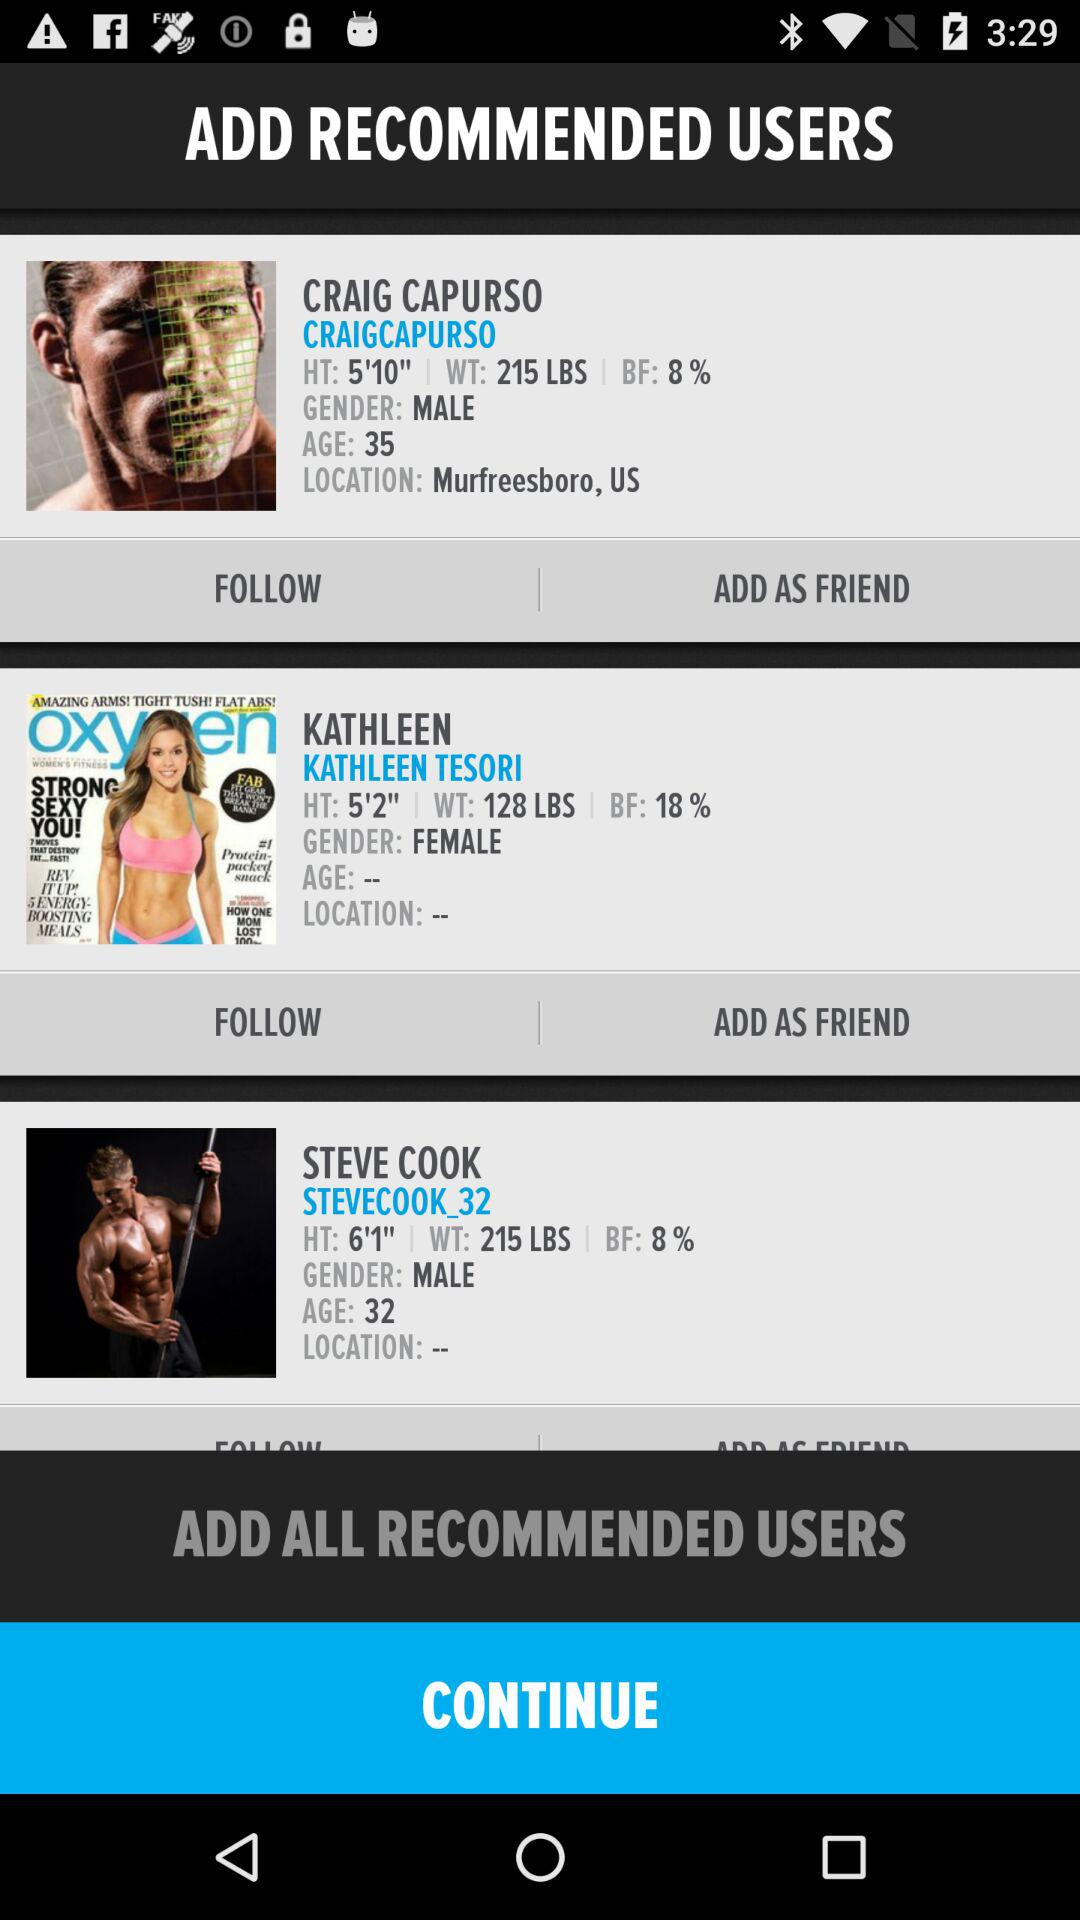How many recommended users are there?
Answer the question using a single word or phrase. 3 